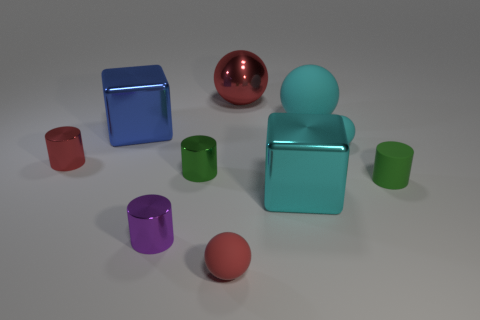There is another matte cylinder that is the same size as the red cylinder; what color is it? green 